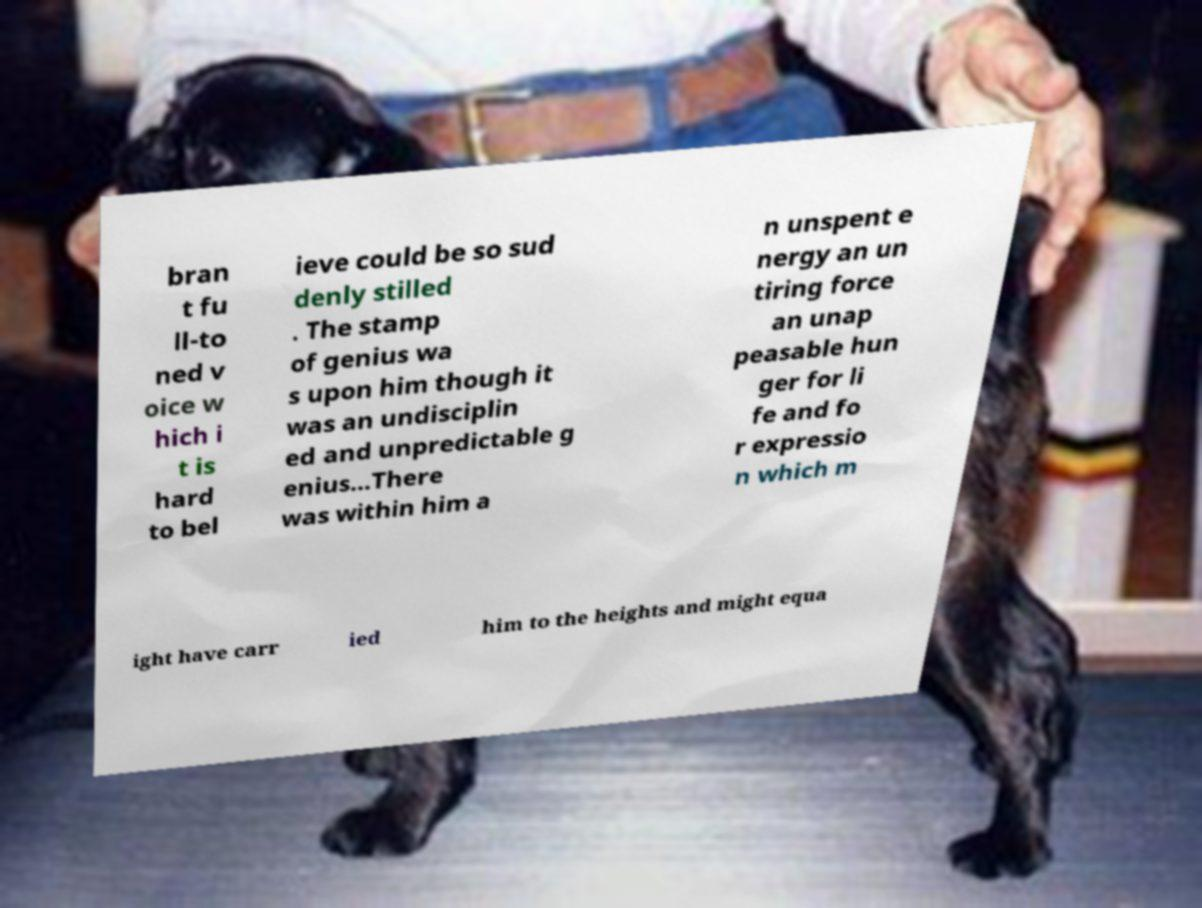I need the written content from this picture converted into text. Can you do that? bran t fu ll-to ned v oice w hich i t is hard to bel ieve could be so sud denly stilled . The stamp of genius wa s upon him though it was an undisciplin ed and unpredictable g enius...There was within him a n unspent e nergy an un tiring force an unap peasable hun ger for li fe and fo r expressio n which m ight have carr ied him to the heights and might equa 